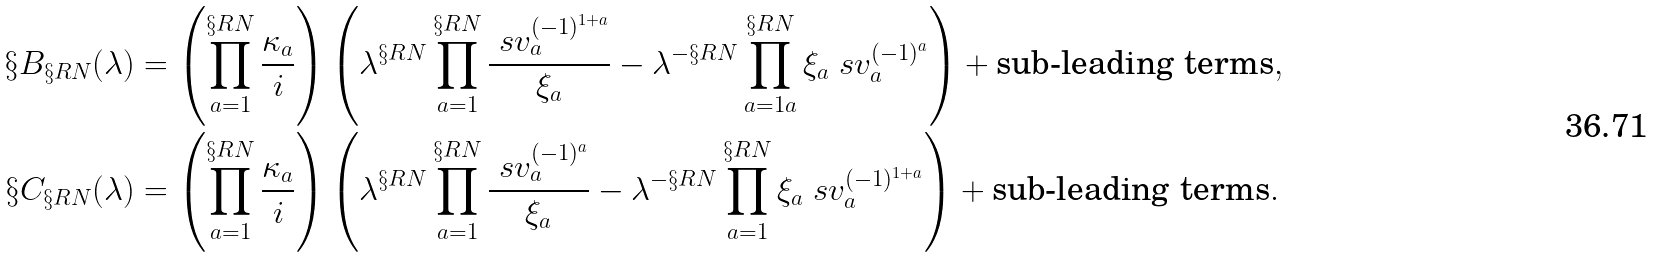<formula> <loc_0><loc_0><loc_500><loc_500>\S B _ { \S R N } ( \lambda ) & = \left ( \prod _ { a = 1 } ^ { \S R N } \frac { \kappa _ { a } } { i } \right ) \left ( \lambda ^ { \S R N } \prod _ { a = 1 } ^ { \S R N } \frac { \ s v _ { a } ^ { ( - 1 ) ^ { 1 + a } } } { \xi _ { a } } - \lambda ^ { - \S R N } \prod _ { a = 1 a } ^ { \S R N } \xi _ { a } \ s v _ { a } ^ { ( - 1 ) ^ { a } } \right ) + \text {sub-leading terms} , \\ \S C _ { \S R N } ( \lambda ) & = \left ( \prod _ { a = 1 } ^ { \S R N } \frac { \kappa _ { a } } { i } \right ) \left ( \lambda ^ { \S R N } \prod _ { a = 1 } ^ { \S R N } \frac { \ s v _ { a } ^ { ( - 1 ) ^ { a } } } { \xi _ { a } } - \lambda ^ { - \S R N } \prod _ { a = 1 } ^ { \S R N } \xi _ { a } \ s v _ { a } ^ { ( - 1 ) ^ { 1 + a } } \right ) + \text {sub-leading terms} .</formula> 